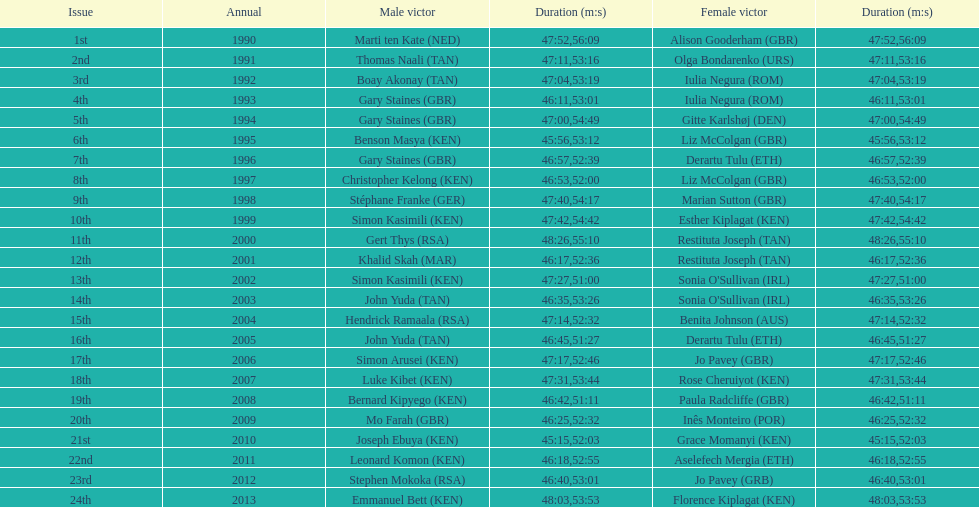The other women's winner with the same finish time as jo pavey in 2012 Iulia Negura. 